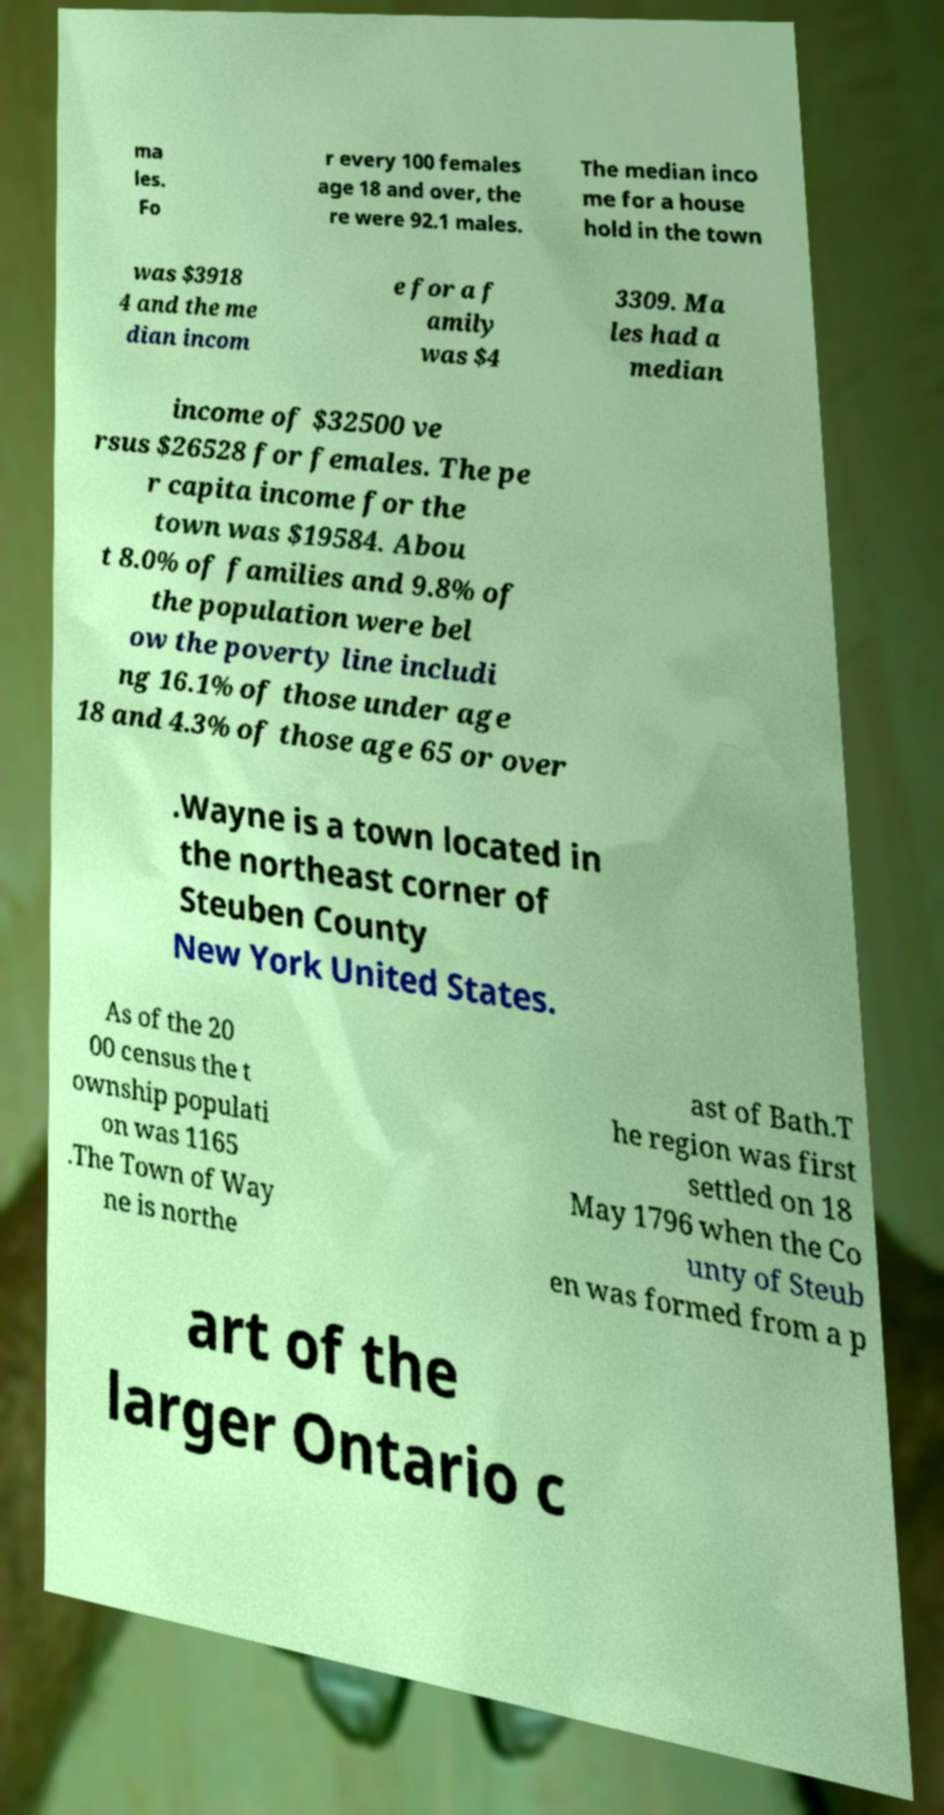I need the written content from this picture converted into text. Can you do that? ma les. Fo r every 100 females age 18 and over, the re were 92.1 males. The median inco me for a house hold in the town was $3918 4 and the me dian incom e for a f amily was $4 3309. Ma les had a median income of $32500 ve rsus $26528 for females. The pe r capita income for the town was $19584. Abou t 8.0% of families and 9.8% of the population were bel ow the poverty line includi ng 16.1% of those under age 18 and 4.3% of those age 65 or over .Wayne is a town located in the northeast corner of Steuben County New York United States. As of the 20 00 census the t ownship populati on was 1165 .The Town of Way ne is northe ast of Bath.T he region was first settled on 18 May 1796 when the Co unty of Steub en was formed from a p art of the larger Ontario c 